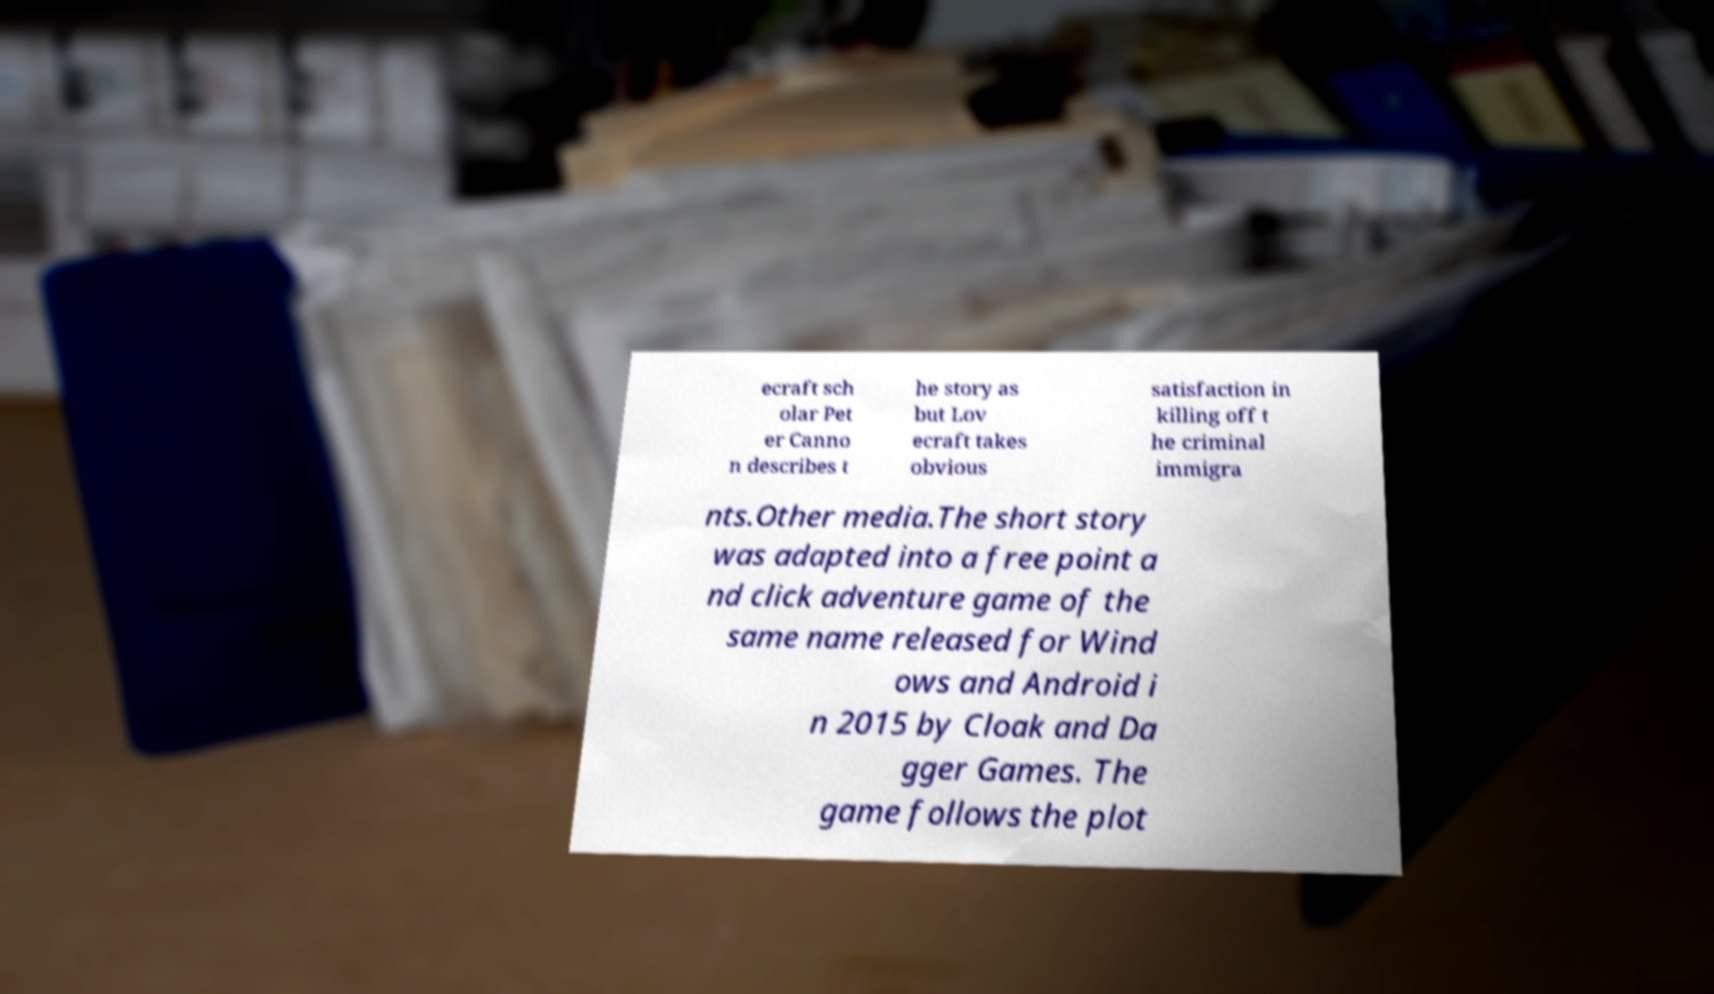There's text embedded in this image that I need extracted. Can you transcribe it verbatim? ecraft sch olar Pet er Canno n describes t he story as but Lov ecraft takes obvious satisfaction in killing off t he criminal immigra nts.Other media.The short story was adapted into a free point a nd click adventure game of the same name released for Wind ows and Android i n 2015 by Cloak and Da gger Games. The game follows the plot 